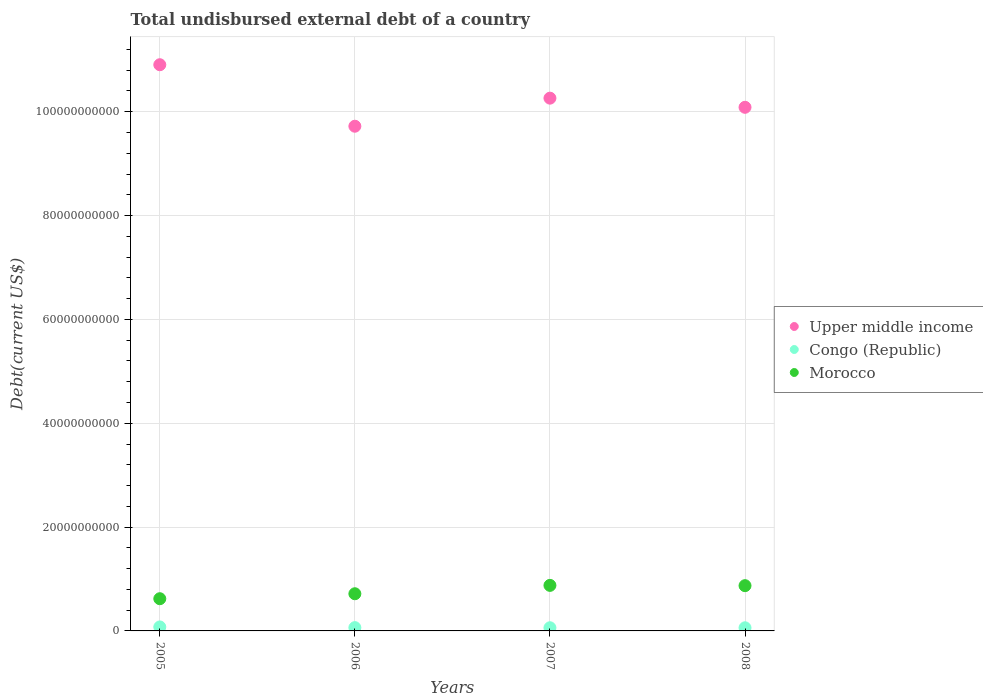How many different coloured dotlines are there?
Ensure brevity in your answer.  3. What is the total undisbursed external debt in Morocco in 2007?
Your response must be concise. 8.77e+09. Across all years, what is the maximum total undisbursed external debt in Upper middle income?
Offer a terse response. 1.09e+11. Across all years, what is the minimum total undisbursed external debt in Upper middle income?
Provide a short and direct response. 9.72e+1. In which year was the total undisbursed external debt in Congo (Republic) maximum?
Keep it short and to the point. 2005. In which year was the total undisbursed external debt in Upper middle income minimum?
Keep it short and to the point. 2006. What is the total total undisbursed external debt in Morocco in the graph?
Offer a terse response. 3.09e+1. What is the difference between the total undisbursed external debt in Upper middle income in 2007 and that in 2008?
Make the answer very short. 1.76e+09. What is the difference between the total undisbursed external debt in Morocco in 2006 and the total undisbursed external debt in Congo (Republic) in 2008?
Give a very brief answer. 6.56e+09. What is the average total undisbursed external debt in Congo (Republic) per year?
Provide a succinct answer. 6.53e+08. In the year 2008, what is the difference between the total undisbursed external debt in Upper middle income and total undisbursed external debt in Morocco?
Give a very brief answer. 9.21e+1. In how many years, is the total undisbursed external debt in Upper middle income greater than 20000000000 US$?
Give a very brief answer. 4. What is the ratio of the total undisbursed external debt in Congo (Republic) in 2005 to that in 2006?
Offer a terse response. 1.21. What is the difference between the highest and the second highest total undisbursed external debt in Congo (Republic)?
Offer a very short reply. 1.31e+08. What is the difference between the highest and the lowest total undisbursed external debt in Morocco?
Ensure brevity in your answer.  2.57e+09. In how many years, is the total undisbursed external debt in Congo (Republic) greater than the average total undisbursed external debt in Congo (Republic) taken over all years?
Offer a terse response. 1. Is the sum of the total undisbursed external debt in Upper middle income in 2006 and 2007 greater than the maximum total undisbursed external debt in Morocco across all years?
Give a very brief answer. Yes. How many years are there in the graph?
Keep it short and to the point. 4. Are the values on the major ticks of Y-axis written in scientific E-notation?
Your response must be concise. No. Does the graph contain any zero values?
Your answer should be very brief. No. Does the graph contain grids?
Offer a very short reply. Yes. Where does the legend appear in the graph?
Your response must be concise. Center right. How many legend labels are there?
Offer a terse response. 3. How are the legend labels stacked?
Provide a short and direct response. Vertical. What is the title of the graph?
Your response must be concise. Total undisbursed external debt of a country. What is the label or title of the X-axis?
Offer a terse response. Years. What is the label or title of the Y-axis?
Offer a terse response. Debt(current US$). What is the Debt(current US$) of Upper middle income in 2005?
Provide a succinct answer. 1.09e+11. What is the Debt(current US$) in Congo (Republic) in 2005?
Keep it short and to the point. 7.65e+08. What is the Debt(current US$) of Morocco in 2005?
Ensure brevity in your answer.  6.20e+09. What is the Debt(current US$) in Upper middle income in 2006?
Provide a short and direct response. 9.72e+1. What is the Debt(current US$) in Congo (Republic) in 2006?
Offer a terse response. 6.35e+08. What is the Debt(current US$) in Morocco in 2006?
Your answer should be compact. 7.16e+09. What is the Debt(current US$) in Upper middle income in 2007?
Make the answer very short. 1.03e+11. What is the Debt(current US$) in Congo (Republic) in 2007?
Your response must be concise. 6.10e+08. What is the Debt(current US$) in Morocco in 2007?
Provide a succinct answer. 8.77e+09. What is the Debt(current US$) in Upper middle income in 2008?
Ensure brevity in your answer.  1.01e+11. What is the Debt(current US$) of Congo (Republic) in 2008?
Give a very brief answer. 6.03e+08. What is the Debt(current US$) of Morocco in 2008?
Your answer should be compact. 8.72e+09. Across all years, what is the maximum Debt(current US$) of Upper middle income?
Make the answer very short. 1.09e+11. Across all years, what is the maximum Debt(current US$) of Congo (Republic)?
Ensure brevity in your answer.  7.65e+08. Across all years, what is the maximum Debt(current US$) of Morocco?
Offer a very short reply. 8.77e+09. Across all years, what is the minimum Debt(current US$) of Upper middle income?
Give a very brief answer. 9.72e+1. Across all years, what is the minimum Debt(current US$) in Congo (Republic)?
Your answer should be very brief. 6.03e+08. Across all years, what is the minimum Debt(current US$) in Morocco?
Offer a terse response. 6.20e+09. What is the total Debt(current US$) of Upper middle income in the graph?
Your answer should be very brief. 4.10e+11. What is the total Debt(current US$) in Congo (Republic) in the graph?
Keep it short and to the point. 2.61e+09. What is the total Debt(current US$) of Morocco in the graph?
Your answer should be very brief. 3.09e+1. What is the difference between the Debt(current US$) of Upper middle income in 2005 and that in 2006?
Give a very brief answer. 1.18e+1. What is the difference between the Debt(current US$) in Congo (Republic) in 2005 and that in 2006?
Make the answer very short. 1.31e+08. What is the difference between the Debt(current US$) of Morocco in 2005 and that in 2006?
Your response must be concise. -9.55e+08. What is the difference between the Debt(current US$) in Upper middle income in 2005 and that in 2007?
Your answer should be very brief. 6.44e+09. What is the difference between the Debt(current US$) in Congo (Republic) in 2005 and that in 2007?
Your response must be concise. 1.55e+08. What is the difference between the Debt(current US$) in Morocco in 2005 and that in 2007?
Provide a succinct answer. -2.57e+09. What is the difference between the Debt(current US$) in Upper middle income in 2005 and that in 2008?
Offer a very short reply. 8.20e+09. What is the difference between the Debt(current US$) in Congo (Republic) in 2005 and that in 2008?
Your answer should be compact. 1.62e+08. What is the difference between the Debt(current US$) of Morocco in 2005 and that in 2008?
Offer a very short reply. -2.51e+09. What is the difference between the Debt(current US$) of Upper middle income in 2006 and that in 2007?
Make the answer very short. -5.41e+09. What is the difference between the Debt(current US$) of Congo (Republic) in 2006 and that in 2007?
Make the answer very short. 2.50e+07. What is the difference between the Debt(current US$) of Morocco in 2006 and that in 2007?
Ensure brevity in your answer.  -1.61e+09. What is the difference between the Debt(current US$) of Upper middle income in 2006 and that in 2008?
Provide a short and direct response. -3.65e+09. What is the difference between the Debt(current US$) of Congo (Republic) in 2006 and that in 2008?
Make the answer very short. 3.18e+07. What is the difference between the Debt(current US$) in Morocco in 2006 and that in 2008?
Provide a succinct answer. -1.56e+09. What is the difference between the Debt(current US$) in Upper middle income in 2007 and that in 2008?
Offer a very short reply. 1.76e+09. What is the difference between the Debt(current US$) in Congo (Republic) in 2007 and that in 2008?
Ensure brevity in your answer.  6.79e+06. What is the difference between the Debt(current US$) of Morocco in 2007 and that in 2008?
Offer a terse response. 5.37e+07. What is the difference between the Debt(current US$) in Upper middle income in 2005 and the Debt(current US$) in Congo (Republic) in 2006?
Your response must be concise. 1.08e+11. What is the difference between the Debt(current US$) in Upper middle income in 2005 and the Debt(current US$) in Morocco in 2006?
Your answer should be compact. 1.02e+11. What is the difference between the Debt(current US$) in Congo (Republic) in 2005 and the Debt(current US$) in Morocco in 2006?
Provide a short and direct response. -6.39e+09. What is the difference between the Debt(current US$) of Upper middle income in 2005 and the Debt(current US$) of Congo (Republic) in 2007?
Offer a terse response. 1.08e+11. What is the difference between the Debt(current US$) in Upper middle income in 2005 and the Debt(current US$) in Morocco in 2007?
Ensure brevity in your answer.  1.00e+11. What is the difference between the Debt(current US$) of Congo (Republic) in 2005 and the Debt(current US$) of Morocco in 2007?
Offer a very short reply. -8.01e+09. What is the difference between the Debt(current US$) in Upper middle income in 2005 and the Debt(current US$) in Congo (Republic) in 2008?
Your answer should be very brief. 1.08e+11. What is the difference between the Debt(current US$) in Upper middle income in 2005 and the Debt(current US$) in Morocco in 2008?
Ensure brevity in your answer.  1.00e+11. What is the difference between the Debt(current US$) of Congo (Republic) in 2005 and the Debt(current US$) of Morocco in 2008?
Your answer should be compact. -7.95e+09. What is the difference between the Debt(current US$) in Upper middle income in 2006 and the Debt(current US$) in Congo (Republic) in 2007?
Your answer should be very brief. 9.66e+1. What is the difference between the Debt(current US$) in Upper middle income in 2006 and the Debt(current US$) in Morocco in 2007?
Provide a short and direct response. 8.84e+1. What is the difference between the Debt(current US$) in Congo (Republic) in 2006 and the Debt(current US$) in Morocco in 2007?
Provide a succinct answer. -8.14e+09. What is the difference between the Debt(current US$) in Upper middle income in 2006 and the Debt(current US$) in Congo (Republic) in 2008?
Your response must be concise. 9.66e+1. What is the difference between the Debt(current US$) of Upper middle income in 2006 and the Debt(current US$) of Morocco in 2008?
Make the answer very short. 8.85e+1. What is the difference between the Debt(current US$) in Congo (Republic) in 2006 and the Debt(current US$) in Morocco in 2008?
Keep it short and to the point. -8.08e+09. What is the difference between the Debt(current US$) of Upper middle income in 2007 and the Debt(current US$) of Congo (Republic) in 2008?
Offer a terse response. 1.02e+11. What is the difference between the Debt(current US$) of Upper middle income in 2007 and the Debt(current US$) of Morocco in 2008?
Provide a succinct answer. 9.39e+1. What is the difference between the Debt(current US$) in Congo (Republic) in 2007 and the Debt(current US$) in Morocco in 2008?
Provide a short and direct response. -8.11e+09. What is the average Debt(current US$) in Upper middle income per year?
Make the answer very short. 1.02e+11. What is the average Debt(current US$) of Congo (Republic) per year?
Your answer should be very brief. 6.53e+08. What is the average Debt(current US$) in Morocco per year?
Keep it short and to the point. 7.71e+09. In the year 2005, what is the difference between the Debt(current US$) in Upper middle income and Debt(current US$) in Congo (Republic)?
Your answer should be very brief. 1.08e+11. In the year 2005, what is the difference between the Debt(current US$) in Upper middle income and Debt(current US$) in Morocco?
Your answer should be compact. 1.03e+11. In the year 2005, what is the difference between the Debt(current US$) in Congo (Republic) and Debt(current US$) in Morocco?
Your response must be concise. -5.44e+09. In the year 2006, what is the difference between the Debt(current US$) of Upper middle income and Debt(current US$) of Congo (Republic)?
Offer a terse response. 9.66e+1. In the year 2006, what is the difference between the Debt(current US$) of Upper middle income and Debt(current US$) of Morocco?
Make the answer very short. 9.00e+1. In the year 2006, what is the difference between the Debt(current US$) in Congo (Republic) and Debt(current US$) in Morocco?
Keep it short and to the point. -6.52e+09. In the year 2007, what is the difference between the Debt(current US$) in Upper middle income and Debt(current US$) in Congo (Republic)?
Keep it short and to the point. 1.02e+11. In the year 2007, what is the difference between the Debt(current US$) in Upper middle income and Debt(current US$) in Morocco?
Ensure brevity in your answer.  9.38e+1. In the year 2007, what is the difference between the Debt(current US$) in Congo (Republic) and Debt(current US$) in Morocco?
Your response must be concise. -8.16e+09. In the year 2008, what is the difference between the Debt(current US$) of Upper middle income and Debt(current US$) of Congo (Republic)?
Your response must be concise. 1.00e+11. In the year 2008, what is the difference between the Debt(current US$) in Upper middle income and Debt(current US$) in Morocco?
Keep it short and to the point. 9.21e+1. In the year 2008, what is the difference between the Debt(current US$) of Congo (Republic) and Debt(current US$) of Morocco?
Your answer should be very brief. -8.11e+09. What is the ratio of the Debt(current US$) of Upper middle income in 2005 to that in 2006?
Offer a terse response. 1.12. What is the ratio of the Debt(current US$) of Congo (Republic) in 2005 to that in 2006?
Your answer should be compact. 1.21. What is the ratio of the Debt(current US$) in Morocco in 2005 to that in 2006?
Provide a short and direct response. 0.87. What is the ratio of the Debt(current US$) in Upper middle income in 2005 to that in 2007?
Keep it short and to the point. 1.06. What is the ratio of the Debt(current US$) in Congo (Republic) in 2005 to that in 2007?
Keep it short and to the point. 1.26. What is the ratio of the Debt(current US$) in Morocco in 2005 to that in 2007?
Keep it short and to the point. 0.71. What is the ratio of the Debt(current US$) in Upper middle income in 2005 to that in 2008?
Your answer should be very brief. 1.08. What is the ratio of the Debt(current US$) of Congo (Republic) in 2005 to that in 2008?
Keep it short and to the point. 1.27. What is the ratio of the Debt(current US$) in Morocco in 2005 to that in 2008?
Make the answer very short. 0.71. What is the ratio of the Debt(current US$) of Upper middle income in 2006 to that in 2007?
Ensure brevity in your answer.  0.95. What is the ratio of the Debt(current US$) of Congo (Republic) in 2006 to that in 2007?
Offer a very short reply. 1.04. What is the ratio of the Debt(current US$) of Morocco in 2006 to that in 2007?
Offer a very short reply. 0.82. What is the ratio of the Debt(current US$) in Upper middle income in 2006 to that in 2008?
Ensure brevity in your answer.  0.96. What is the ratio of the Debt(current US$) of Congo (Republic) in 2006 to that in 2008?
Give a very brief answer. 1.05. What is the ratio of the Debt(current US$) in Morocco in 2006 to that in 2008?
Offer a very short reply. 0.82. What is the ratio of the Debt(current US$) of Upper middle income in 2007 to that in 2008?
Provide a short and direct response. 1.02. What is the ratio of the Debt(current US$) of Congo (Republic) in 2007 to that in 2008?
Give a very brief answer. 1.01. What is the ratio of the Debt(current US$) in Morocco in 2007 to that in 2008?
Make the answer very short. 1.01. What is the difference between the highest and the second highest Debt(current US$) of Upper middle income?
Ensure brevity in your answer.  6.44e+09. What is the difference between the highest and the second highest Debt(current US$) of Congo (Republic)?
Offer a very short reply. 1.31e+08. What is the difference between the highest and the second highest Debt(current US$) of Morocco?
Your response must be concise. 5.37e+07. What is the difference between the highest and the lowest Debt(current US$) in Upper middle income?
Your answer should be compact. 1.18e+1. What is the difference between the highest and the lowest Debt(current US$) of Congo (Republic)?
Offer a terse response. 1.62e+08. What is the difference between the highest and the lowest Debt(current US$) of Morocco?
Offer a very short reply. 2.57e+09. 